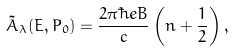Convert formula to latex. <formula><loc_0><loc_0><loc_500><loc_500>\tilde { A } _ { \lambda } ( E , P _ { 0 } ) = \frac { 2 \pi \hbar { e } B } { c } \left ( n + \frac { 1 } { 2 } \right ) ,</formula> 